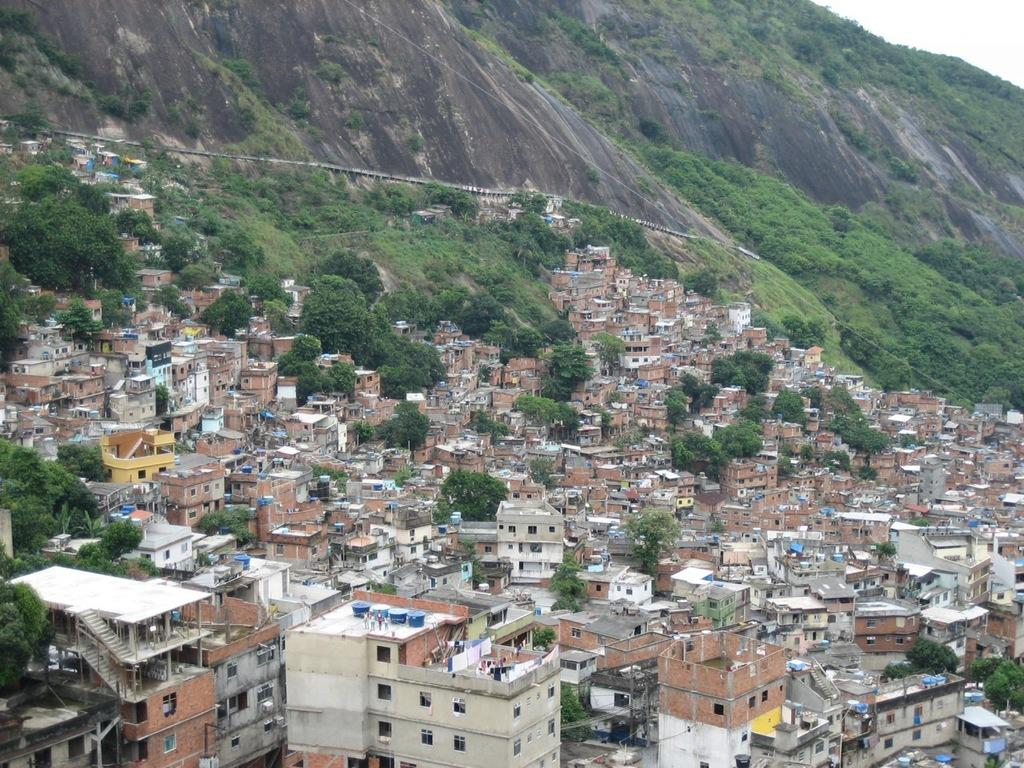What type of location is shown in the image? The image depicts a city. What structures can be seen in the city? There are buildings in the image. Are there any natural elements present in the city? Yes, there are trees in the image. What else can be seen in the image besides buildings and trees? There are poles in the image. What is visible in the background of the city? There is a mountain visible in the background of the image. What is visible at the top of the image? The sky is visible at the top of the image. What rhythm does the mountain follow in the image? The mountain does not follow a rhythm in the image; it is a stationary geological feature. 